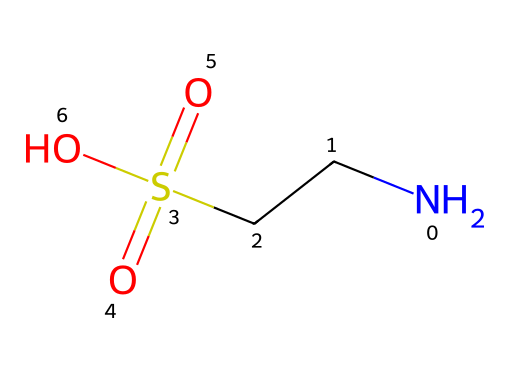What is the name of this chemical? The SMILES representation "NCCS(=O)(=O)O" corresponds to taurine, which is commonly identified by its name as a sulfur-containing amino acid.
Answer: taurine How many oxygen atoms are present in this chemical? In the SMILES, we can observe there are two double-bonded oxygen atoms attached to sulfonic acid (S(=O)(=O)) and one hydroxyl group (O). Therefore, the total is three oxygen atoms.
Answer: three What type of functional group is represented by the "S(=O)(=O)" in this structure? The "S(=O)(=O)" portion indicates a sulfonic acid functional group because sulfur is bonded to two oxygen atoms with double bonds and one oxygen atom with a single bond. This specific arrangement characterizes sulfonic acids.
Answer: sulfonic acid How many total carbon atoms does this compound contain? Analyzing the SMILES representation reveals that there is one carbon atom (from the "CC" notation) in the taurine structure.
Answer: one What role does the amino group (-NH2) play in this compound? The amino group (-NH2), indicated by "N" in the SMILES, contributes to the classification of this molecule as an amino acid, specifically providing the basic property that allows it to act as a neurotransmitter and influence physiological functions.
Answer: amino acid What is the oxidation state of the sulfur atom in this compound? The oxidation state of sulfur in sulfonic acid can be determined by considering the bonds: sulfur is bonded to three oxygens (one with a double bond and two with single bonds) and one carbon, suggesting a +6 oxidation state.
Answer: +6 Does this compound contain any chirality centers? Evaluating the structure shows that taurine has no stereogenic centers; there are no carbon atoms attached to four different substituents, indicating a lack of chirality.
Answer: no 